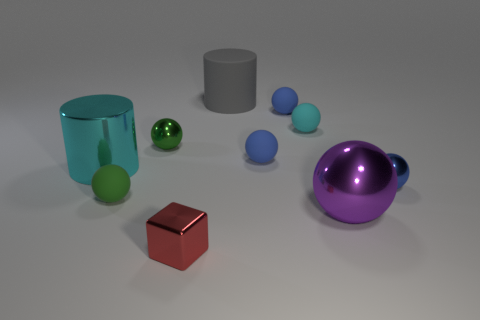What materials appear to be used in the objects depicted in the image? The image showcases various objects that seem to be made from different kinds of materials. The shiny cyan and purple objects have a metallic look suggesting they might be metal. The green and blue objects have a matte finish, possibly indicating plastic or rubber composition. 